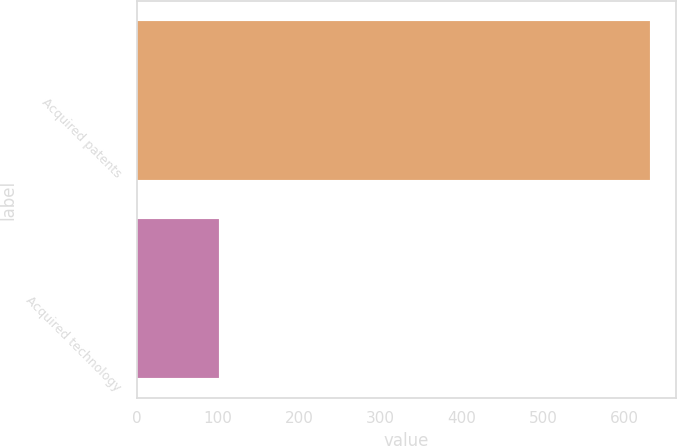<chart> <loc_0><loc_0><loc_500><loc_500><bar_chart><fcel>Acquired patents<fcel>Acquired technology<nl><fcel>631<fcel>101<nl></chart> 